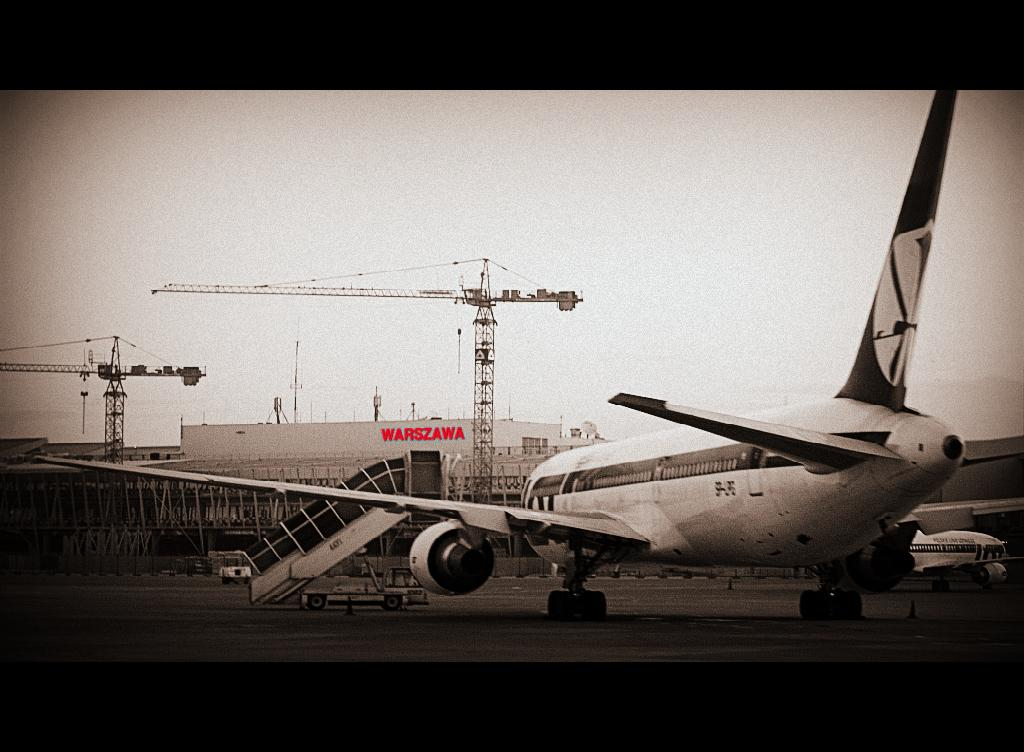What is the main subject of the image? The main subject of the image is an airplane. What other structures or objects can be seen in the image? There is a building, a staircase, and two cranes visible in the image. Where are the cranes located in the image? There is a crane on the left side of the image and another crane on the right side of the image. What is visible at the top of the image? The sky is visible at the top of the image. What type of yam is being served in the school cafeteria in the image? There is no school or cafeteria present in the image, and therefore no yam can be observed. 